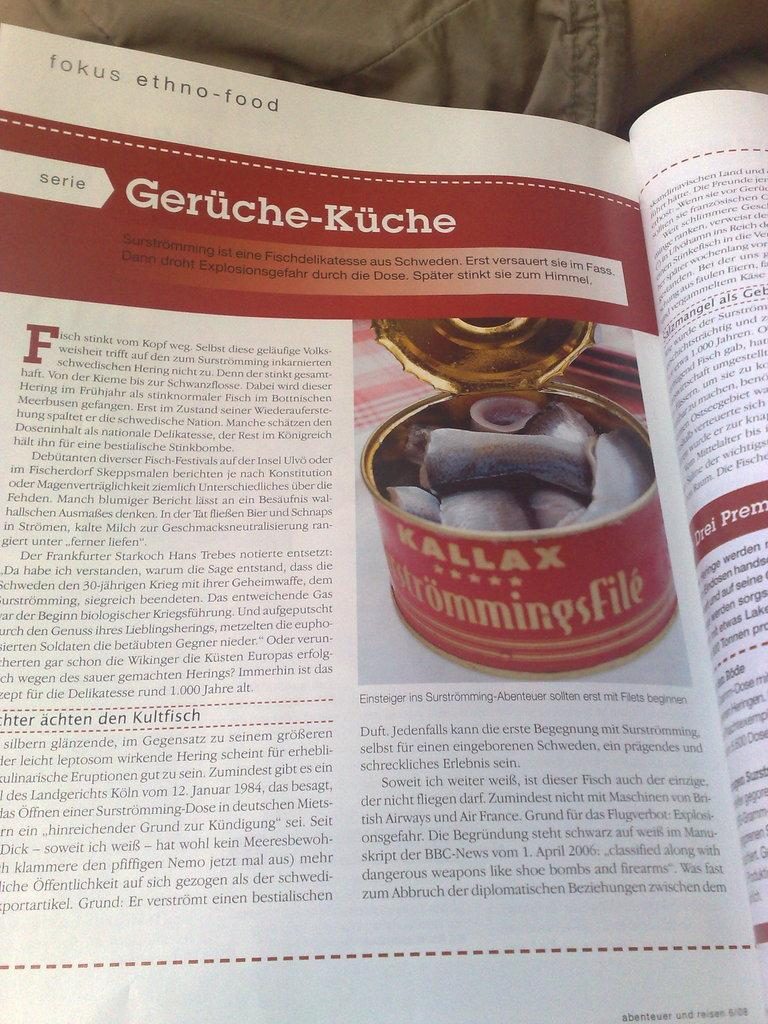Provide a one-sentence caption for the provided image. A magazine artlice talking about different ethnic foods. 